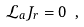Convert formula to latex. <formula><loc_0><loc_0><loc_500><loc_500>\mathcal { L } _ { a } J _ { r } = 0 \ ,</formula> 